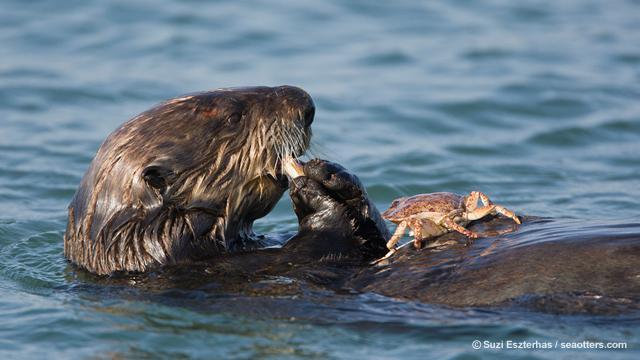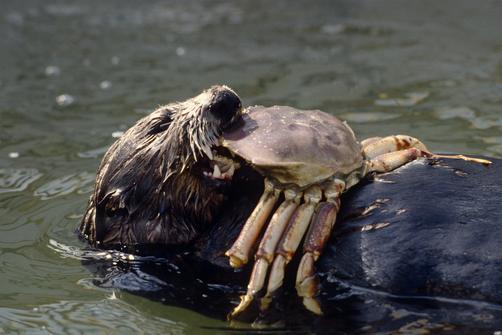The first image is the image on the left, the second image is the image on the right. For the images displayed, is the sentence "There are two otters which each have a crab in their mouth." factually correct? Answer yes or no. Yes. The first image is the image on the left, the second image is the image on the right. Given the left and right images, does the statement "In at least one image there is a floating seal with crab in his mouth." hold true? Answer yes or no. Yes. 